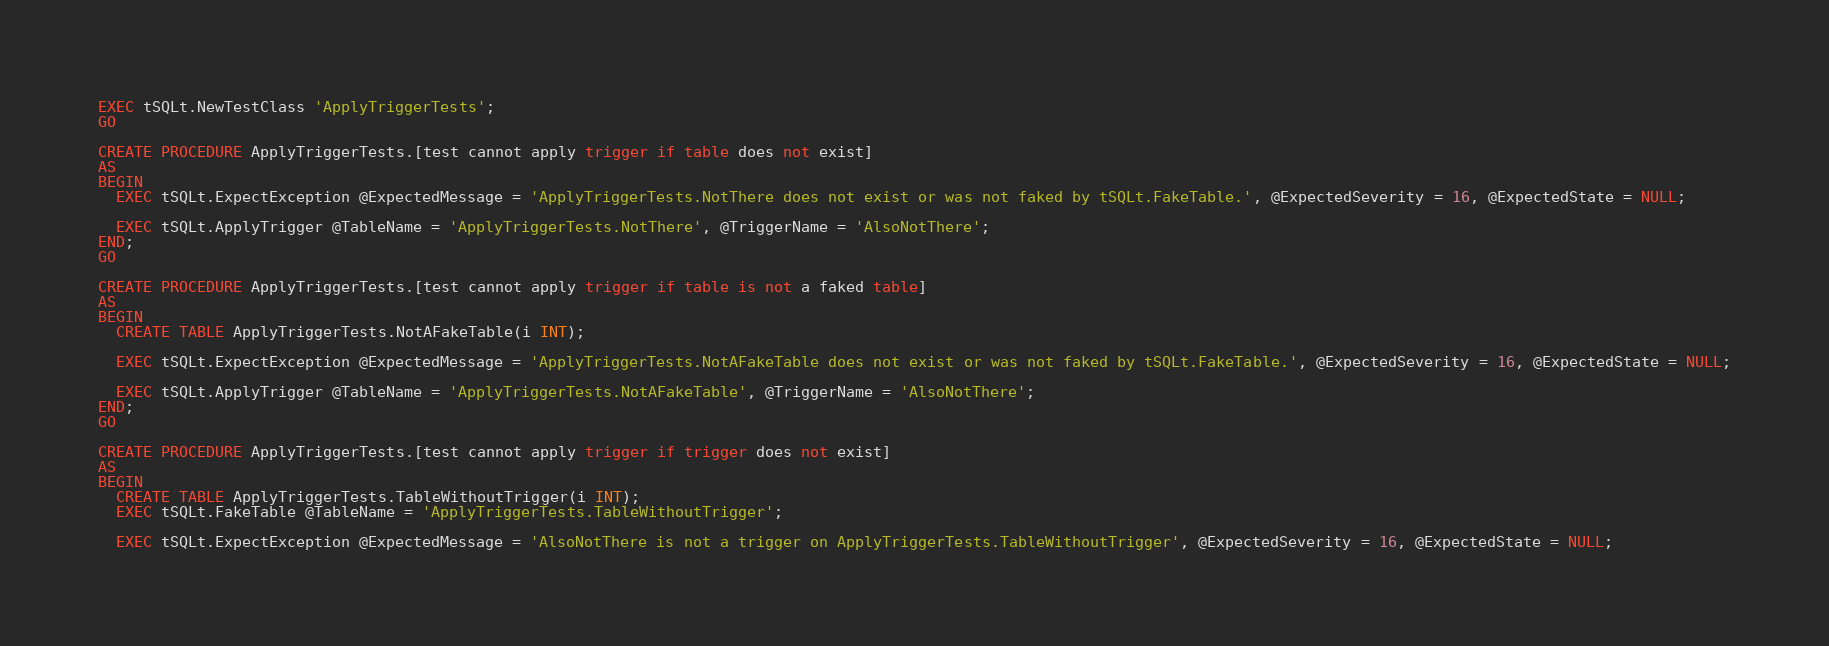<code> <loc_0><loc_0><loc_500><loc_500><_SQL_>EXEC tSQLt.NewTestClass 'ApplyTriggerTests';
GO

CREATE PROCEDURE ApplyTriggerTests.[test cannot apply trigger if table does not exist]
AS
BEGIN
  EXEC tSQLt.ExpectException @ExpectedMessage = 'ApplyTriggerTests.NotThere does not exist or was not faked by tSQLt.FakeTable.', @ExpectedSeverity = 16, @ExpectedState = NULL;

  EXEC tSQLt.ApplyTrigger @TableName = 'ApplyTriggerTests.NotThere', @TriggerName = 'AlsoNotThere';
END;
GO

CREATE PROCEDURE ApplyTriggerTests.[test cannot apply trigger if table is not a faked table]
AS
BEGIN
  CREATE TABLE ApplyTriggerTests.NotAFakeTable(i INT);
  
  EXEC tSQLt.ExpectException @ExpectedMessage = 'ApplyTriggerTests.NotAFakeTable does not exist or was not faked by tSQLt.FakeTable.', @ExpectedSeverity = 16, @ExpectedState = NULL;

  EXEC tSQLt.ApplyTrigger @TableName = 'ApplyTriggerTests.NotAFakeTable', @TriggerName = 'AlsoNotThere';
END;
GO

CREATE PROCEDURE ApplyTriggerTests.[test cannot apply trigger if trigger does not exist]
AS
BEGIN
  CREATE TABLE ApplyTriggerTests.TableWithoutTrigger(i INT);
  EXEC tSQLt.FakeTable @TableName = 'ApplyTriggerTests.TableWithoutTrigger';
  
  EXEC tSQLt.ExpectException @ExpectedMessage = 'AlsoNotThere is not a trigger on ApplyTriggerTests.TableWithoutTrigger', @ExpectedSeverity = 16, @ExpectedState = NULL;
</code> 